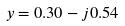Convert formula to latex. <formula><loc_0><loc_0><loc_500><loc_500>y = 0 . 3 0 - j 0 . 5 4</formula> 